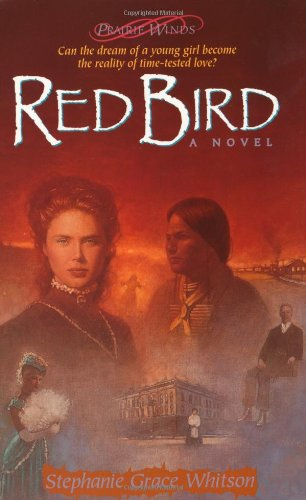What is the title of this book? The title of this book is 'Red Bird', which is the third installment in the Prairie Winds Series by Stephanie Grace Whitson. 